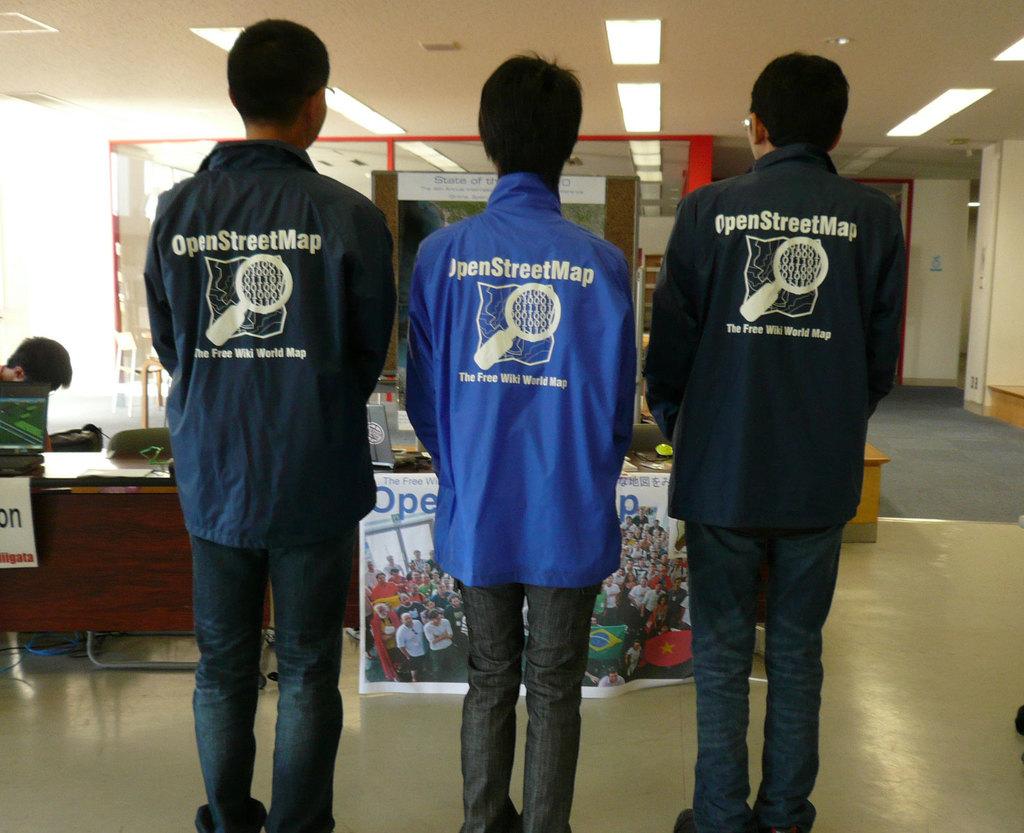What kind of map does their shirt say?
Give a very brief answer. Openstreetmap. Is openstreetmap free?
Make the answer very short. Yes. 